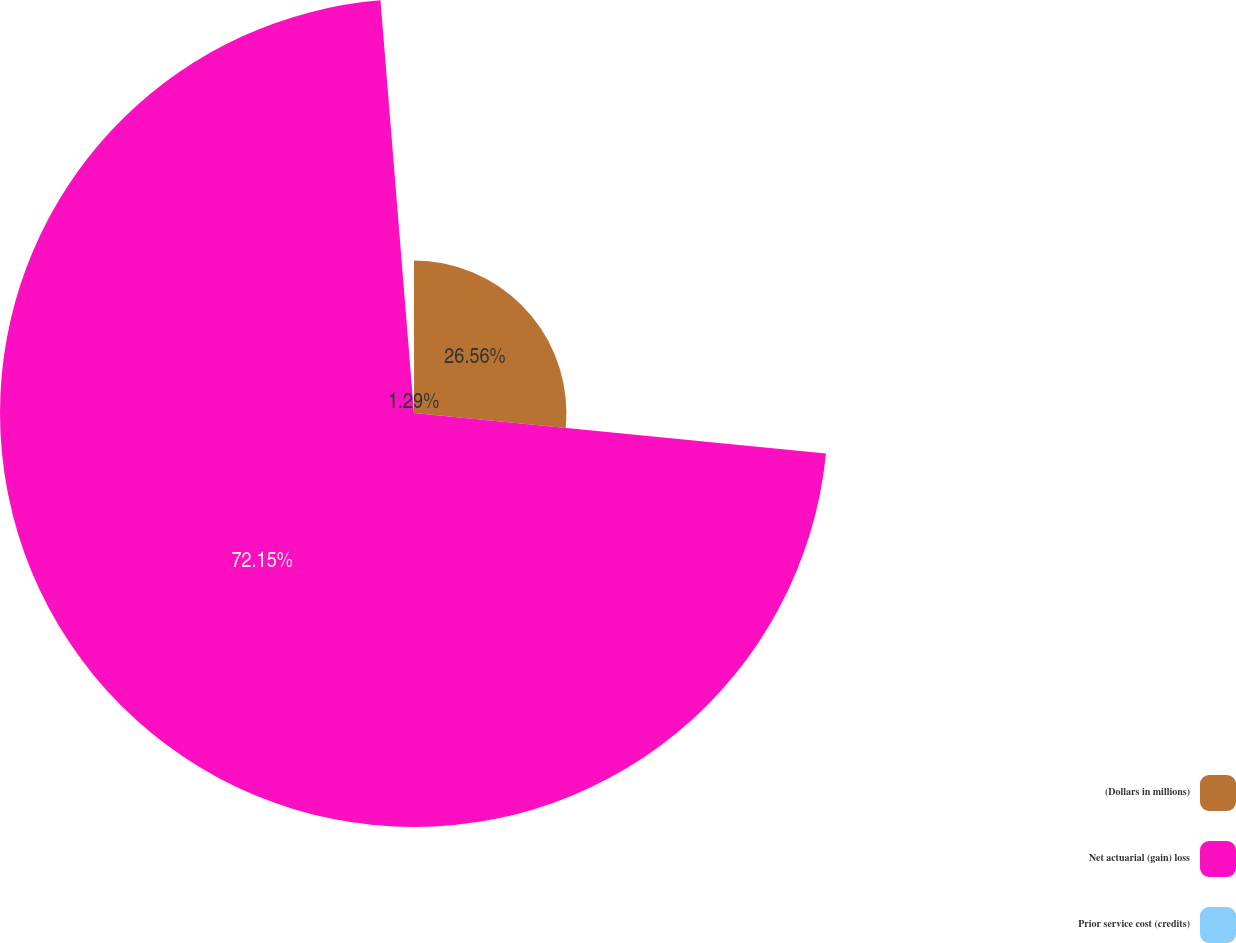<chart> <loc_0><loc_0><loc_500><loc_500><pie_chart><fcel>(Dollars in millions)<fcel>Net actuarial (gain) loss<fcel>Prior service cost (credits)<nl><fcel>26.56%<fcel>72.15%<fcel>1.29%<nl></chart> 